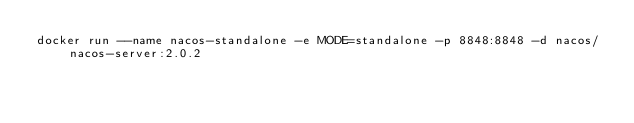Convert code to text. <code><loc_0><loc_0><loc_500><loc_500><_Bash_>docker run --name nacos-standalone -e MODE=standalone -p 8848:8848 -d nacos/nacos-server:2.0.2</code> 